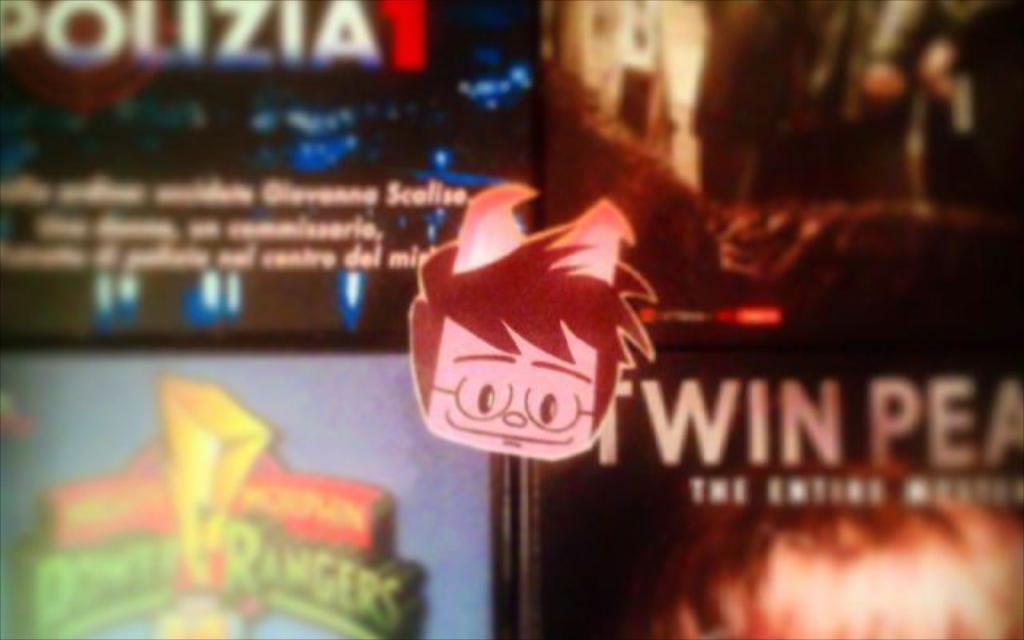What is on the glass object in the image? There is a sticker on a glass object in the image. What can be seen through the glass object? Posters are visible through the glass object. What type of pleasure can be seen enjoying the bird in the image? There is no pleasure or bird present in the image; it features a sticker on a glass object and posters visible through it. 